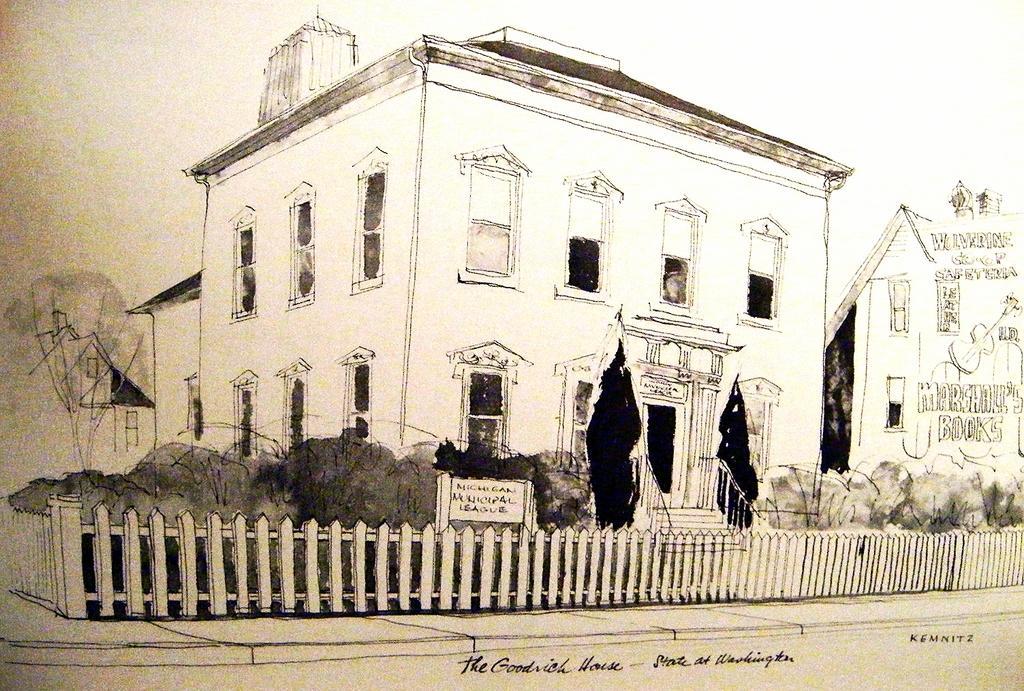In one or two sentences, can you explain what this image depicts? In this picture we can see windows, some text and a few things on the buildings. We can see plants, some fencing, other objects and the sky. There is the text visible at the bottom of the picture. 